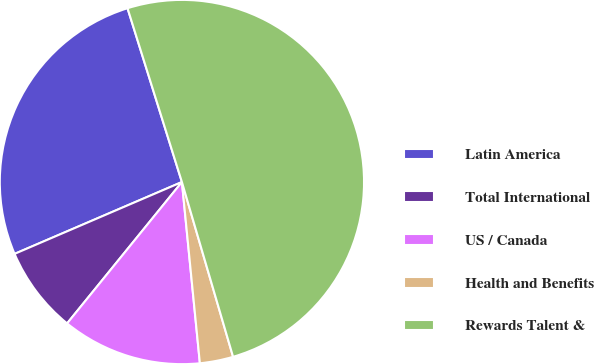Convert chart. <chart><loc_0><loc_0><loc_500><loc_500><pie_chart><fcel>Latin America<fcel>Total International<fcel>US / Canada<fcel>Health and Benefits<fcel>Rewards Talent &<nl><fcel>26.63%<fcel>7.69%<fcel>12.43%<fcel>2.96%<fcel>50.3%<nl></chart> 